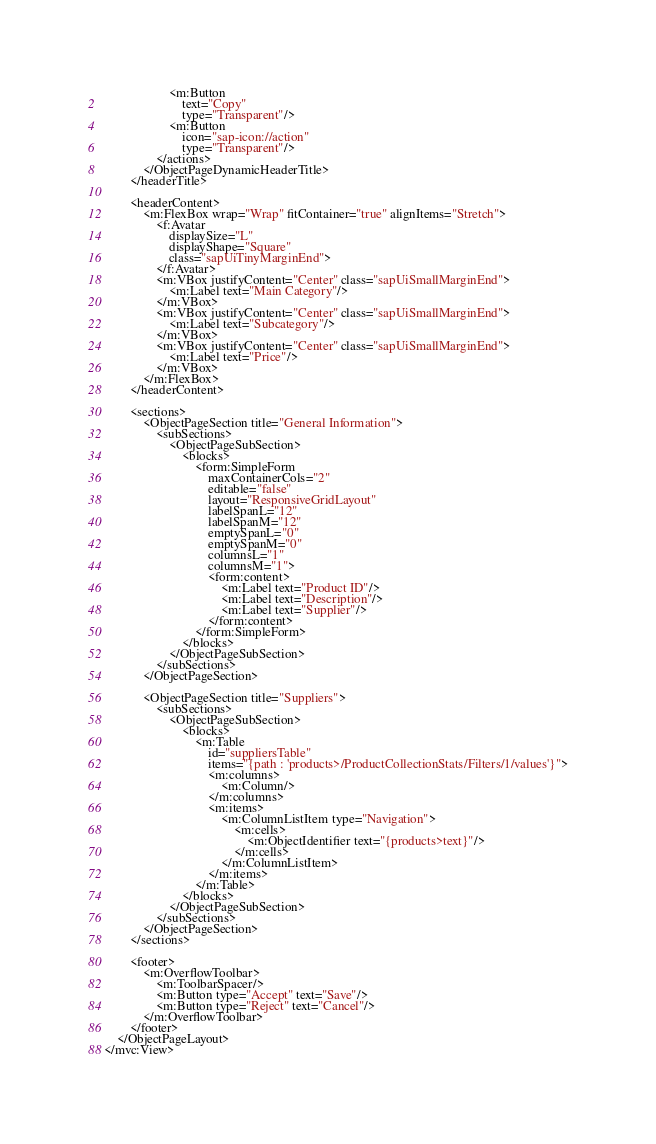Convert code to text. <code><loc_0><loc_0><loc_500><loc_500><_XML_>					<m:Button
						text="Copy"
						type="Transparent"/>
					<m:Button
						icon="sap-icon://action"
						type="Transparent"/>
				</actions>
			</ObjectPageDynamicHeaderTitle>
		</headerTitle>

		<headerContent>
			<m:FlexBox wrap="Wrap" fitContainer="true" alignItems="Stretch">
				<f:Avatar
					displaySize="L"
					displayShape="Square"
					class="sapUiTinyMarginEnd">
				</f:Avatar>
				<m:VBox justifyContent="Center" class="sapUiSmallMarginEnd">
					<m:Label text="Main Category"/>
				</m:VBox>
				<m:VBox justifyContent="Center" class="sapUiSmallMarginEnd">
					<m:Label text="Subcategory"/>
				</m:VBox>
				<m:VBox justifyContent="Center" class="sapUiSmallMarginEnd">
					<m:Label text="Price"/>
				</m:VBox>
			</m:FlexBox>
		</headerContent>

		<sections>
			<ObjectPageSection title="General Information">
				<subSections>
					<ObjectPageSubSection>
						<blocks>
							<form:SimpleForm
								maxContainerCols="2"
								editable="false"
								layout="ResponsiveGridLayout"
								labelSpanL="12"
								labelSpanM="12"
								emptySpanL="0"
								emptySpanM="0"
								columnsL="1"
								columnsM="1">
								<form:content>
									<m:Label text="Product ID"/>
									<m:Label text="Description"/>
									<m:Label text="Supplier"/>
								</form:content>
							</form:SimpleForm>
						</blocks>
					</ObjectPageSubSection>
				</subSections>
			</ObjectPageSection>

			<ObjectPageSection title="Suppliers">
				<subSections>
					<ObjectPageSubSection>
						<blocks>
							<m:Table
								id="suppliersTable"
								items="{path : 'products>/ProductCollectionStats/Filters/1/values'}">
								<m:columns>
									<m:Column/>
								</m:columns>
								<m:items>
									<m:ColumnListItem type="Navigation">
										<m:cells>
											<m:ObjectIdentifier text="{products>text}"/>
										</m:cells>
									</m:ColumnListItem>
								</m:items>
							</m:Table>
						</blocks>
					</ObjectPageSubSection>
				</subSections>
			</ObjectPageSection>
		</sections>

		<footer>
			<m:OverflowToolbar>
				<m:ToolbarSpacer/>
				<m:Button type="Accept" text="Save"/>
				<m:Button type="Reject" text="Cancel"/>
			</m:OverflowToolbar>
		</footer>
	</ObjectPageLayout>
</mvc:View></code> 